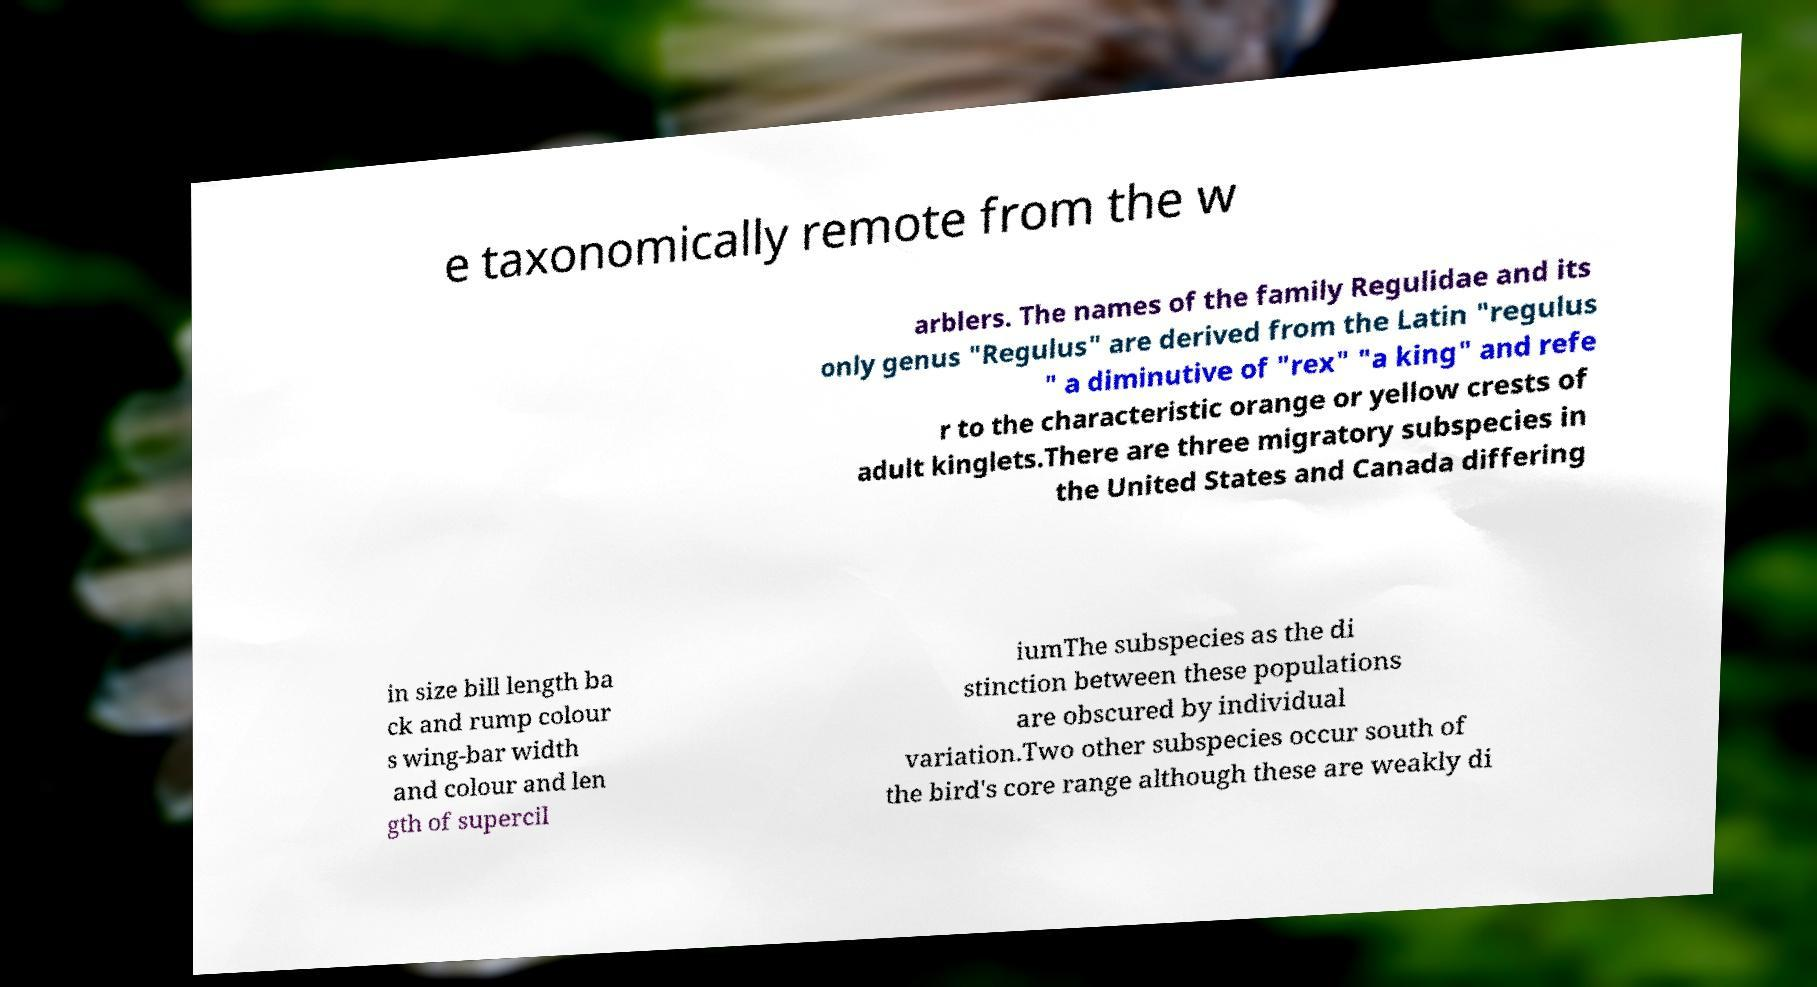Could you extract and type out the text from this image? e taxonomically remote from the w arblers. The names of the family Regulidae and its only genus "Regulus" are derived from the Latin "regulus " a diminutive of "rex" "a king" and refe r to the characteristic orange or yellow crests of adult kinglets.There are three migratory subspecies in the United States and Canada differing in size bill length ba ck and rump colour s wing-bar width and colour and len gth of supercil iumThe subspecies as the di stinction between these populations are obscured by individual variation.Two other subspecies occur south of the bird's core range although these are weakly di 